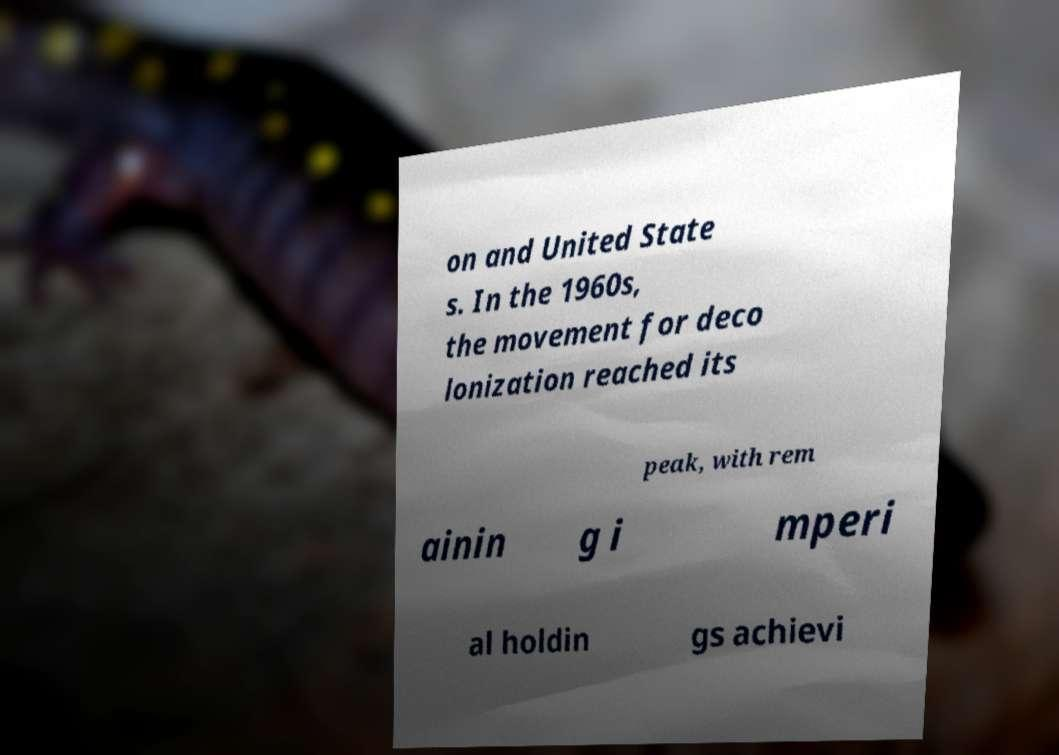Could you assist in decoding the text presented in this image and type it out clearly? on and United State s. In the 1960s, the movement for deco lonization reached its peak, with rem ainin g i mperi al holdin gs achievi 